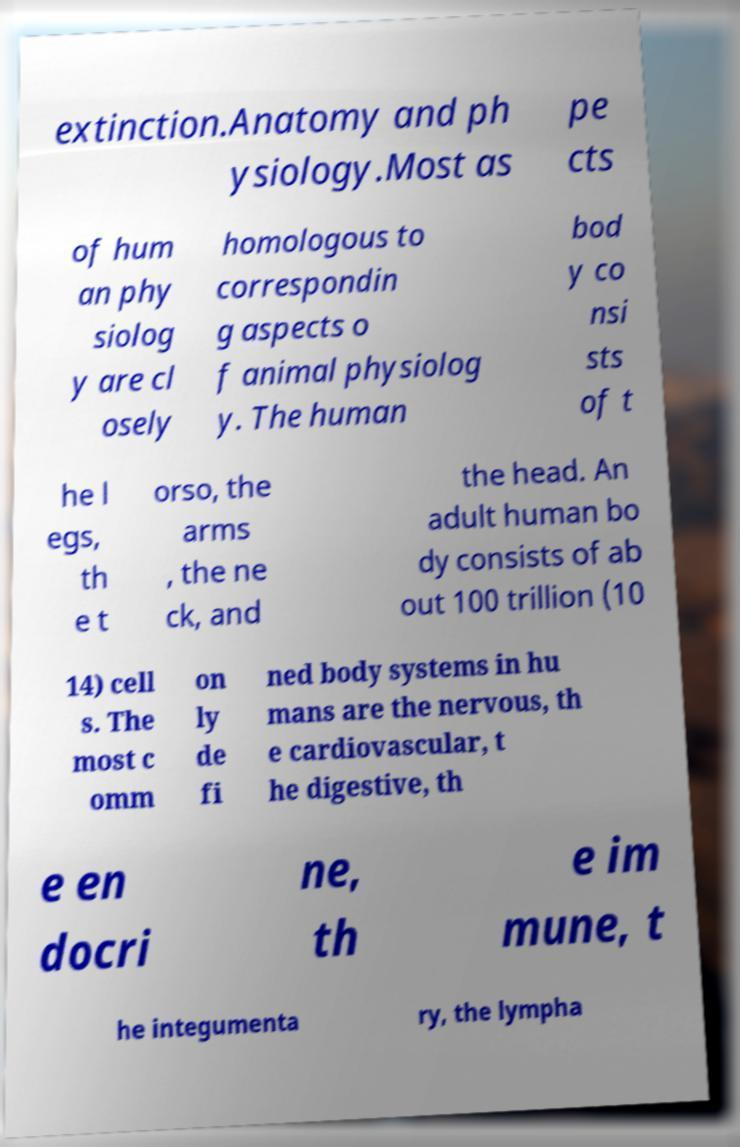I need the written content from this picture converted into text. Can you do that? extinction.Anatomy and ph ysiology.Most as pe cts of hum an phy siolog y are cl osely homologous to correspondin g aspects o f animal physiolog y. The human bod y co nsi sts of t he l egs, th e t orso, the arms , the ne ck, and the head. An adult human bo dy consists of ab out 100 trillion (10 14) cell s. The most c omm on ly de fi ned body systems in hu mans are the nervous, th e cardiovascular, t he digestive, th e en docri ne, th e im mune, t he integumenta ry, the lympha 